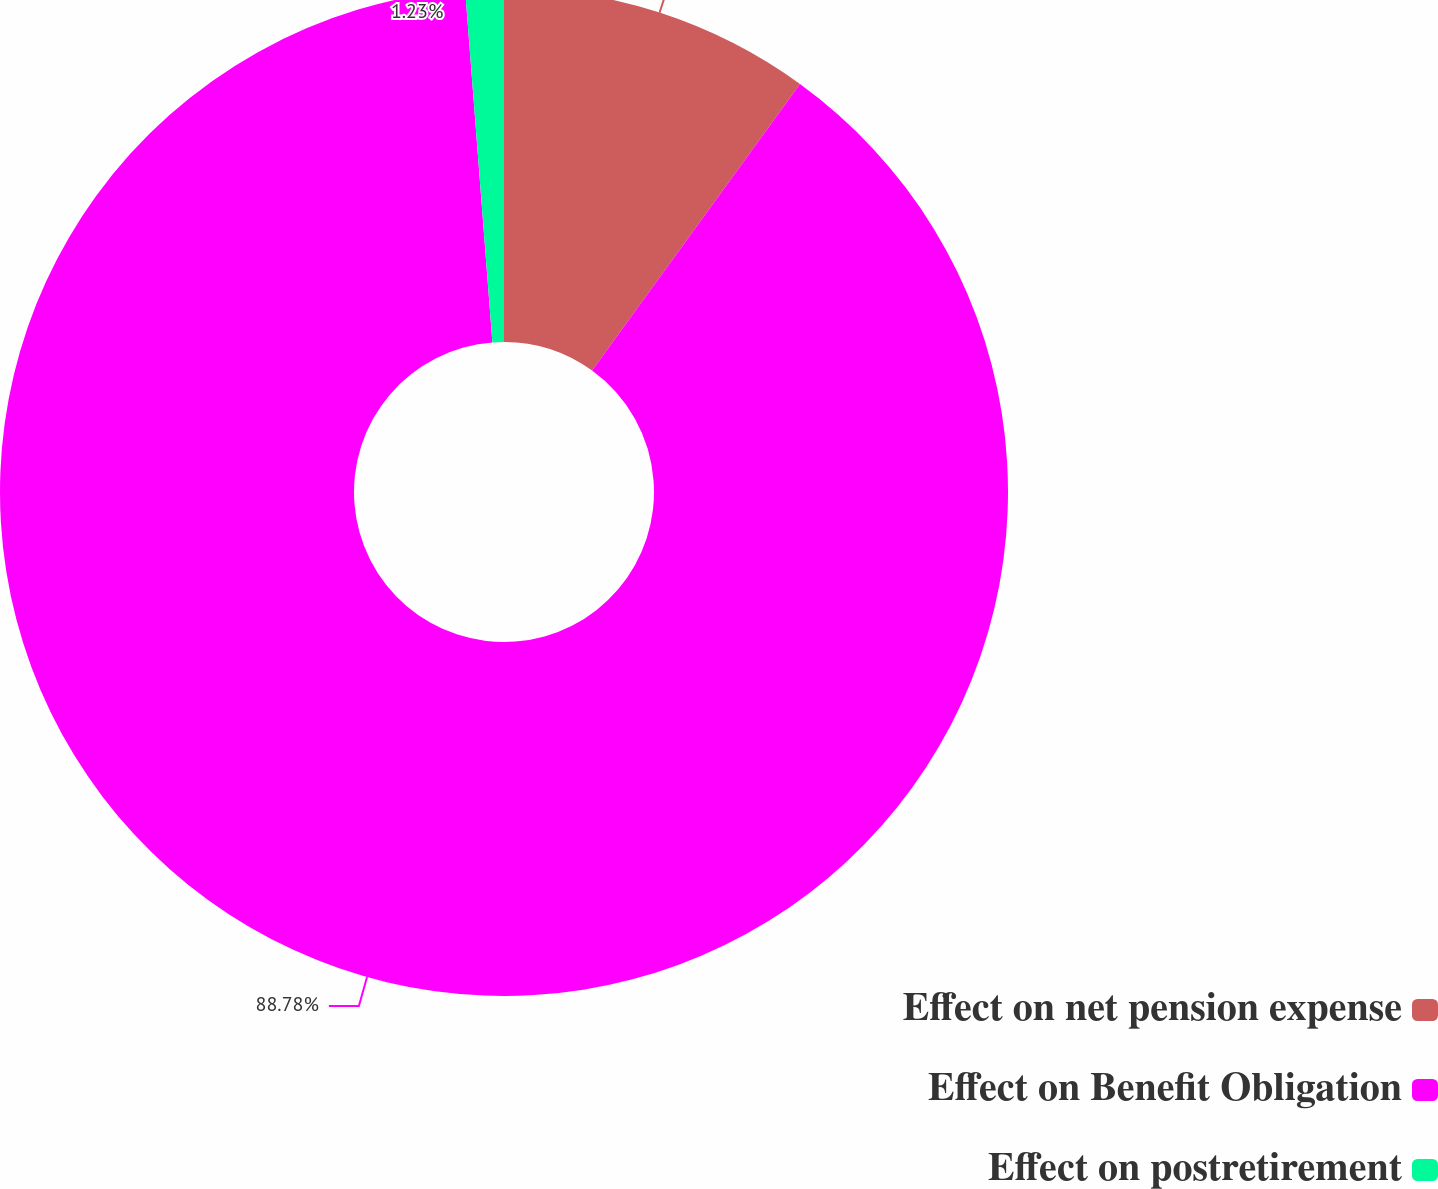Convert chart. <chart><loc_0><loc_0><loc_500><loc_500><pie_chart><fcel>Effect on net pension expense<fcel>Effect on Benefit Obligation<fcel>Effect on postretirement<nl><fcel>9.99%<fcel>88.78%<fcel>1.23%<nl></chart> 